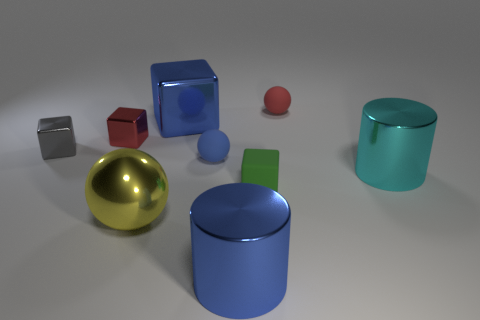Subtract 1 blocks. How many blocks are left? 3 Subtract all yellow blocks. Subtract all green cylinders. How many blocks are left? 4 Subtract all cylinders. How many objects are left? 7 Add 7 yellow shiny spheres. How many yellow shiny spheres are left? 8 Add 4 large metal cubes. How many large metal cubes exist? 5 Subtract 1 cyan cylinders. How many objects are left? 8 Subtract all small blue objects. Subtract all shiny cubes. How many objects are left? 5 